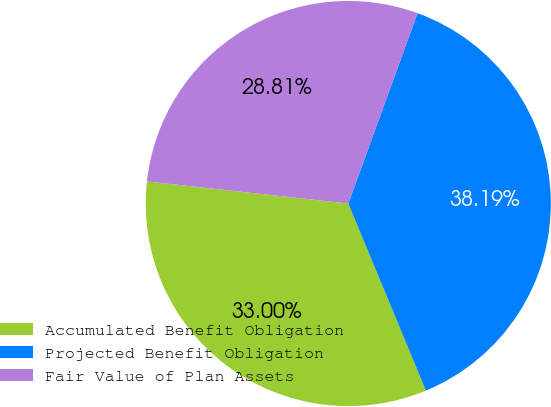Convert chart to OTSL. <chart><loc_0><loc_0><loc_500><loc_500><pie_chart><fcel>Accumulated Benefit Obligation<fcel>Projected Benefit Obligation<fcel>Fair Value of Plan Assets<nl><fcel>33.0%<fcel>38.19%<fcel>28.81%<nl></chart> 